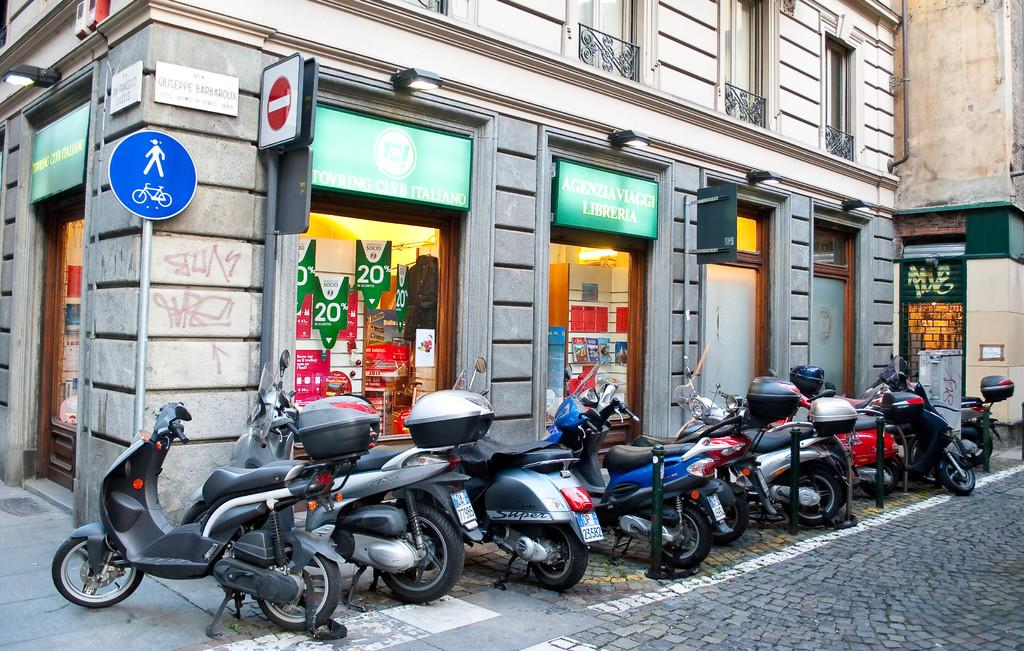What can be seen in the image in terms of transportation? There are many vehicles parked in the image. What type of structures are visible in the image? There are poles and a building visible in the image. What type of path is present in the image? There is a footpath in the image. What type of signage is present in the image? There is a board in the image, which appears to be associated with a shop. What type of light can be seen emanating from the vehicles in the image? There is no light emanating from the vehicles in the image; they are parked and not in use. What type of knowledge can be gained from the board in the image? The board in the image is associated with a shop and does not convey any specific knowledge. 